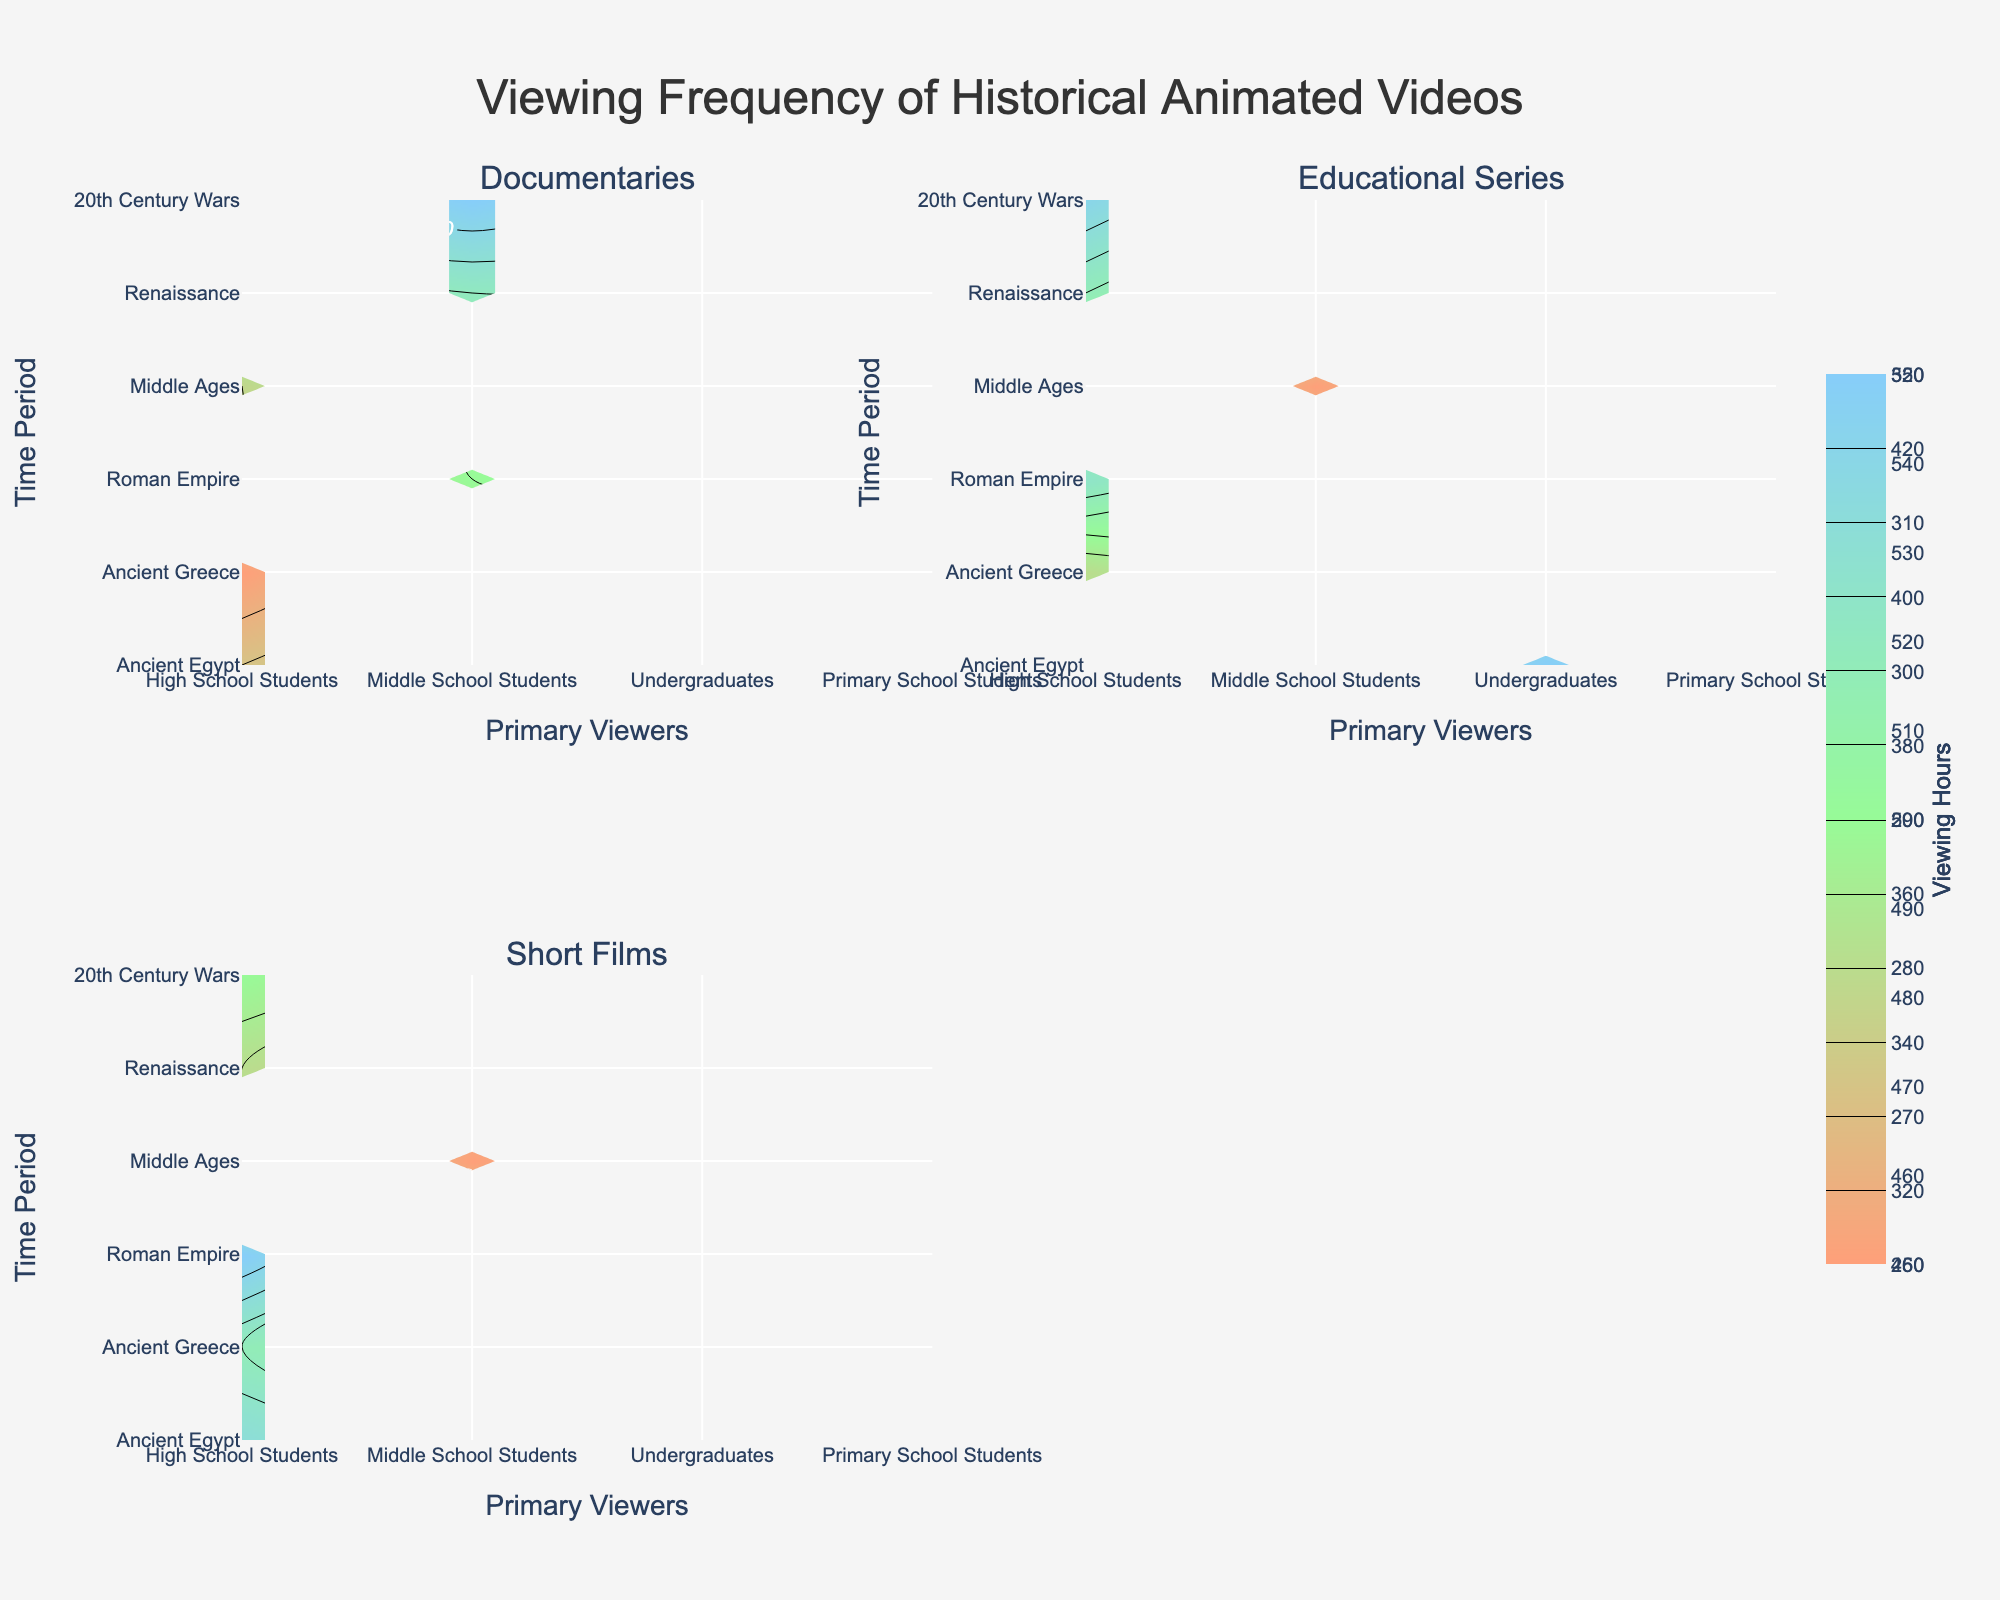What is the title of the figure? The title of the figure is usually displayed prominently at the top, summarizing the content of the chart. In this figure, the title summarizes the data being visualized.
Answer: Viewing Frequency of Historical Animated Videos Which genre has the highest viewing hours in Ancient Greece? To find this answer, look at the contour subplot corresponding to each genre for the time period "Ancient Greece" and see which one has the highest viewing hours represented by the darkest shade or highest contour level.
Answer: Documentaries How do the viewing hours for "Educational Series" by High School Students compare between the Roman Empire and the Middle Ages? For "Educational Series", observe the subplots corresponding to the Roman Empire and the Middle Ages. Compare the contour levels or shades corresponding to High School Students to see which period has higher viewing hours.
Answer: Higher in Roman Empire During which time period did Middle School Students watch the most "Short Films"? To answer this, examine the subplot for "Short Films" and look across the time periods for the contour level or shade indicating the highest viewing hours for Middle School Students.
Answer: Ancient Greece What is the average viewing hour for High School Students watching "Documentaries" across all time periods? Sum the viewing hours for High School Students for "Documentaries" across all time periods and divide by the number of periods. (450 + 480 + 470) / 3 = 1400 / 3
Answer: 466.67 Which primary viewer group had the highest total viewing hours for "Educational Series"? Identify the total viewing hours for each primary viewer group by summing up all their viewing hours across all time periods for "Educational Series". Compare these sums to see which is highest. High School Students: 350 + 400 + 420 + 390 = 1560; Middle School Students: 310; Undergraduates: 430
Answer: High School Students How do the viewing patterns for "Documentaries" and "Short Films" compare for Undergraduates? Compare the contour subplots of "Documentaries" and "Short Films" to see how the viewing hours vary for Undergraduates across different time periods.
Answer: Documentaries higher Which time period had the lowest viewing hours for Primary School Students across all genres? Check all subplots and see which time period has the lowest contour level or lightest shade for Primary School Students across all genres combined.
Answer: Middle Ages What can be inferred about the popularity of historically themed animated videos among primary viewers during the Renaissance period? Look at all genres during the Renaissance period to see the contour levels for the primary viewer groups. Infer overall popularity based on the relative viewing hours.
Answer: Popular with Undergraduates Compare the viewing hours for "Educational Series" by Undergraduates and High School Students during the 20th Century Wars. In the subplot for "Educational Series", compare the contour levels or shades for Undergraduates and High School Students during the 20th Century Wars.
Answer: Higher for Undergraduates 